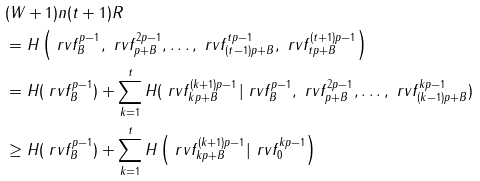<formula> <loc_0><loc_0><loc_500><loc_500>& ( W + 1 ) n ( t + 1 ) R \\ & = H \left ( \ r v f _ { B } ^ { p - 1 } , \ r v f _ { p + B } ^ { 2 p - 1 } , \dots , \ r v f _ { ( t - 1 ) p + B } ^ { t p - 1 } , \ r v f _ { t p + B } ^ { ( t + 1 ) p - 1 } \right ) \\ & = H ( \ r v f _ { B } ^ { p - 1 } ) + \sum _ { k = 1 } ^ { t } H ( \ r v f _ { k p + B } ^ { ( k + 1 ) p - 1 } | \ r v f _ { B } ^ { p - 1 } , \ r v f _ { p + B } ^ { 2 p - 1 } , \dots , \ r v f _ { ( k - 1 ) p + B } ^ { k p - 1 } ) \\ & \geq H ( \ r v f _ { B } ^ { p - 1 } ) + \sum _ { k = 1 } ^ { t } H \left ( \ r v f _ { k p + B } ^ { ( k + 1 ) p - 1 } | \ r v f _ { 0 } ^ { k p - 1 } \right )</formula> 